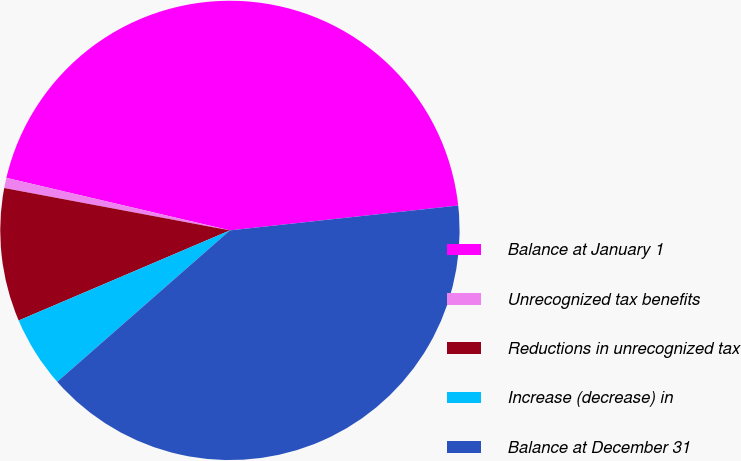Convert chart to OTSL. <chart><loc_0><loc_0><loc_500><loc_500><pie_chart><fcel>Balance at January 1<fcel>Unrecognized tax benefits<fcel>Reductions in unrecognized tax<fcel>Increase (decrease) in<fcel>Balance at December 31<nl><fcel>44.6%<fcel>0.72%<fcel>9.37%<fcel>5.04%<fcel>40.27%<nl></chart> 